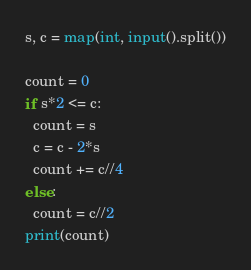<code> <loc_0><loc_0><loc_500><loc_500><_Python_>s, c = map(int, input().split())

count = 0
if s*2 <= c:
  count = s
  c = c - 2*s
  count += c//4
else:
  count = c//2
print(count)</code> 